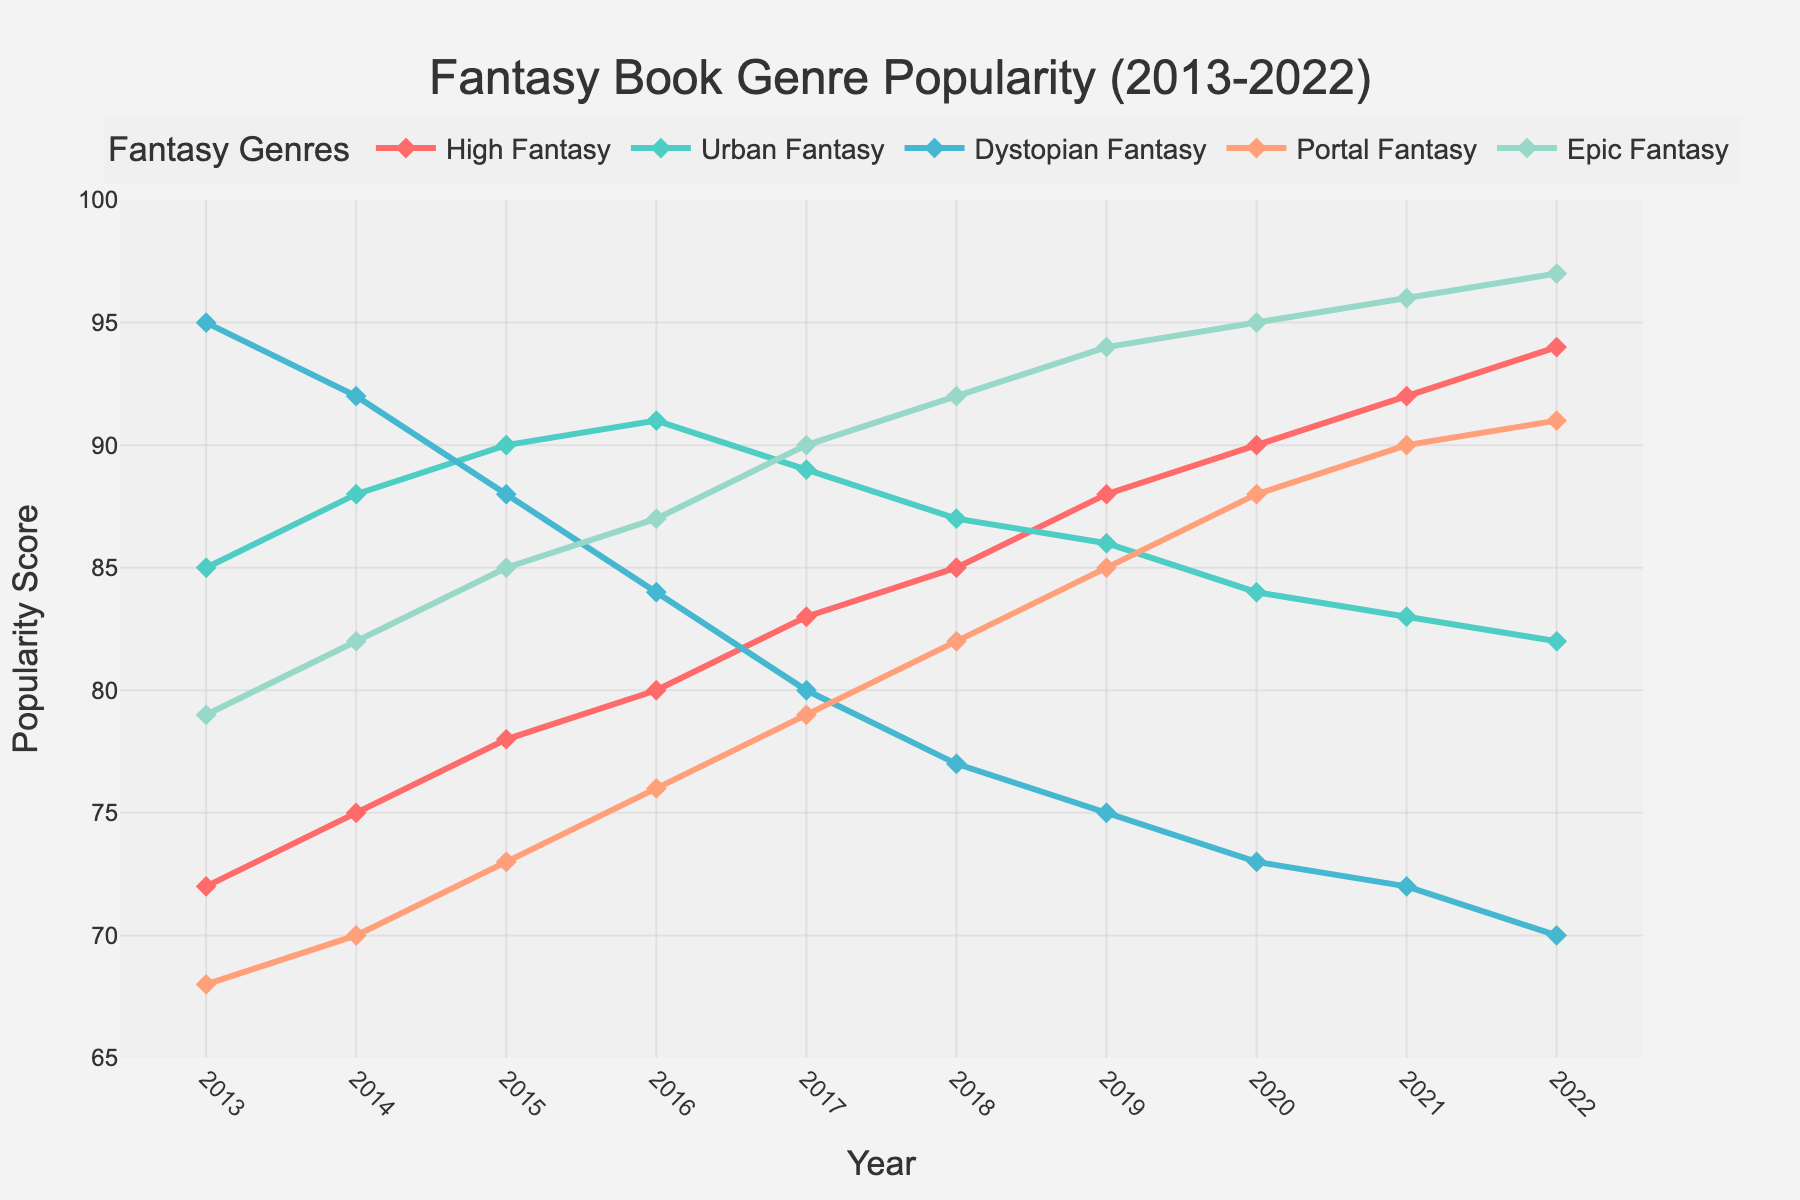Which genre showed the greatest increase in popularity over the years? To identify the genre with the greatest increase, subtract the 2013 popularity score from the 2022 popularity score for each genre, then compare the differences. The increases are as follows: High Fantasy (94-72=22), Urban Fantasy (82-85=-3), Dystopian Fantasy (70-95=-25), Portal Fantasy (91-68=23), and Epic Fantasy (97-79=18). Portal Fantasy shows the greatest increase.
Answer: Portal Fantasy Which genre was most popular in 2017? To find the most popular genre in 2017, refer to the 2017 values and compare: High Fantasy (83), Urban Fantasy (89), Dystopian Fantasy (80), Portal Fantasy (79), Epic Fantasy (90). Epic Fantasy has the highest value.
Answer: Epic Fantasy What is the average popularity score for Urban Fantasy from 2013 to 2022? Calculate the average by summing the Urban Fantasy scores from each year and then dividing by the number of years: (85+88+90+91+89+87+86+84+83+82)/10 = 865/10.
Answer: 86.5 By how much did the popularity of Dystopian Fantasy decrease from 2013 to 2022? Subtract the 2022 popularity score from the 2013 score for Dystopian Fantasy: 95 - 70 = 25.
Answer: 25 In which year did High Fantasy surpass Urban Fantasy in popularity? Compare yearly scores for High Fantasy and Urban Fantasy until High Fantasy's value exceeds Urban Fantasy's. In 2019, High Fantasy (88) surpasses Urban Fantasy (86).
Answer: 2019 Which genre consistently increased in popularity every year? Review the yearly scores for each genre to identify one whose popularity increases each year. High Fantasy increases every year from 2013 to 2022 without any drops.
Answer: High Fantasy What is the difference in popularity scores between Portal Fantasy and Epic Fantasy in 2020? Subtract the 2020 score of Portal Fantasy from that of Epic Fantasy: 95 - 88 = 7.
Answer: 7 Which genre was the least popular in 2022? Compare the 2022 scores for all genres: High Fantasy (94), Urban Fantasy (82), Dystopian Fantasy (70), Portal Fantasy (91), Epic Fantasy (97). Dystopian Fantasy has the lowest score.
Answer: Dystopian Fantasy Between which years did Urban Fantasy see its largest decrease in popularity? Identify the largest single-year drop by comparing year-over-year differences for Urban Fantasy: The largest drop is from 2016 to 2017 (91 - 89 = 2). However, the biggest decrease is from 2014 to 2015 (90-88 = 2).
Answer: 2016-2017 